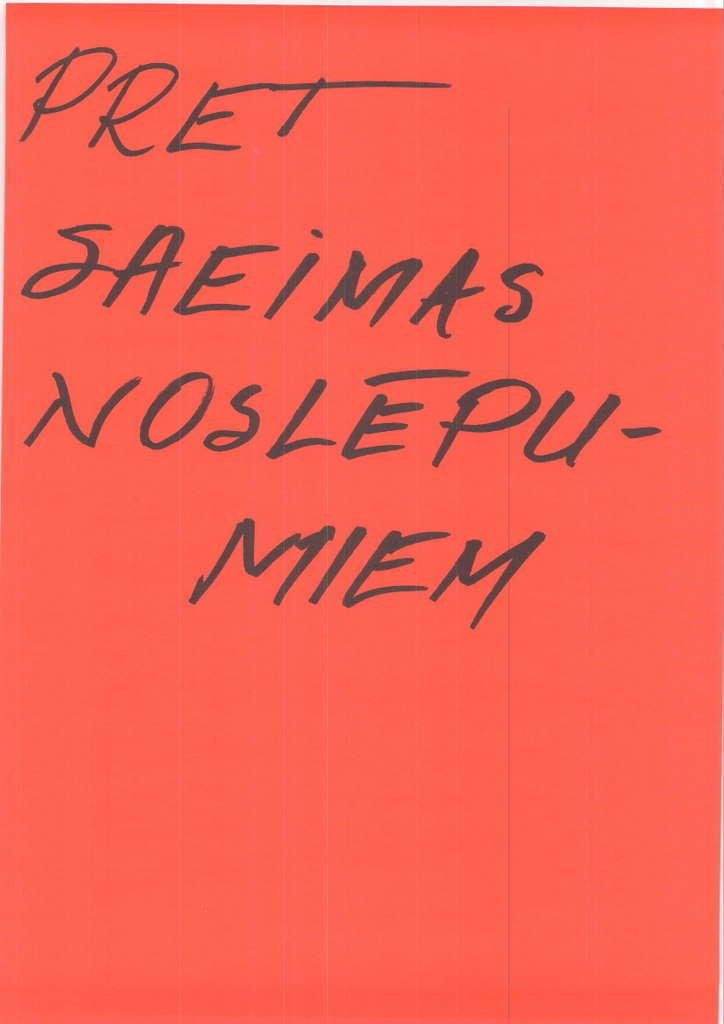<image>
Provide a brief description of the given image. the name pret that has a red background 